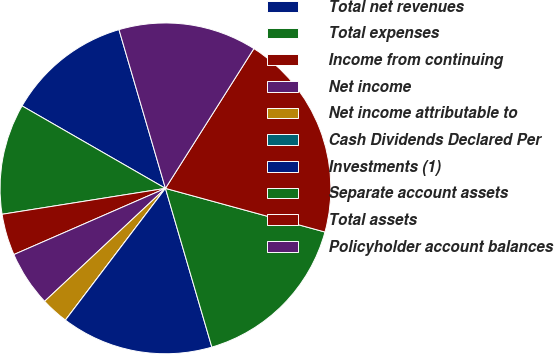<chart> <loc_0><loc_0><loc_500><loc_500><pie_chart><fcel>Total net revenues<fcel>Total expenses<fcel>Income from continuing<fcel>Net income<fcel>Net income attributable to<fcel>Cash Dividends Declared Per<fcel>Investments (1)<fcel>Separate account assets<fcel>Total assets<fcel>Policyholder account balances<nl><fcel>12.16%<fcel>10.81%<fcel>4.05%<fcel>5.41%<fcel>2.7%<fcel>0.0%<fcel>14.86%<fcel>16.22%<fcel>20.27%<fcel>13.51%<nl></chart> 